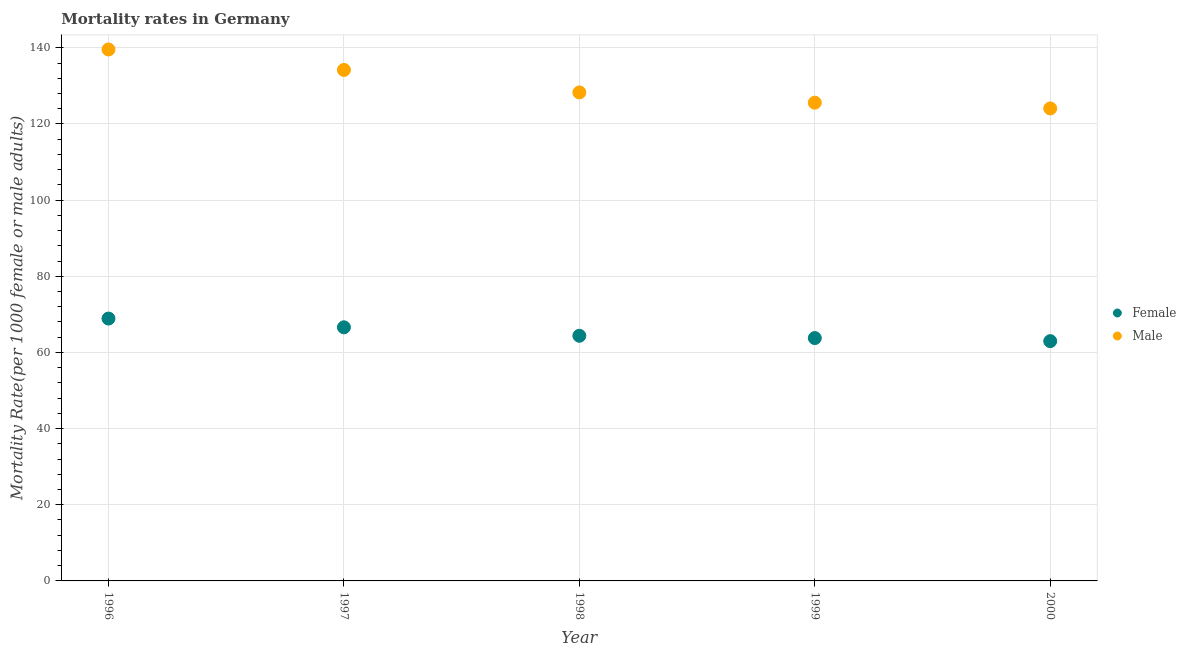How many different coloured dotlines are there?
Provide a succinct answer. 2. Is the number of dotlines equal to the number of legend labels?
Provide a short and direct response. Yes. What is the male mortality rate in 1996?
Your answer should be compact. 139.57. Across all years, what is the maximum male mortality rate?
Provide a short and direct response. 139.57. Across all years, what is the minimum male mortality rate?
Your response must be concise. 124.08. In which year was the female mortality rate minimum?
Provide a short and direct response. 2000. What is the total male mortality rate in the graph?
Offer a terse response. 651.74. What is the difference between the female mortality rate in 1999 and that in 2000?
Your response must be concise. 0.81. What is the difference between the female mortality rate in 1999 and the male mortality rate in 2000?
Your response must be concise. -60.3. What is the average male mortality rate per year?
Provide a succinct answer. 130.35. In the year 1998, what is the difference between the male mortality rate and female mortality rate?
Offer a terse response. 63.91. What is the ratio of the male mortality rate in 1998 to that in 2000?
Provide a succinct answer. 1.03. Is the male mortality rate in 1998 less than that in 1999?
Ensure brevity in your answer.  No. What is the difference between the highest and the second highest female mortality rate?
Your response must be concise. 2.3. What is the difference between the highest and the lowest male mortality rate?
Your answer should be compact. 15.49. In how many years, is the female mortality rate greater than the average female mortality rate taken over all years?
Make the answer very short. 2. Does the female mortality rate monotonically increase over the years?
Offer a terse response. No. Is the male mortality rate strictly greater than the female mortality rate over the years?
Provide a succinct answer. Yes. What is the difference between two consecutive major ticks on the Y-axis?
Ensure brevity in your answer.  20. Does the graph contain any zero values?
Provide a succinct answer. No. Does the graph contain grids?
Provide a short and direct response. Yes. What is the title of the graph?
Offer a very short reply. Mortality rates in Germany. What is the label or title of the X-axis?
Your answer should be very brief. Year. What is the label or title of the Y-axis?
Offer a very short reply. Mortality Rate(per 1000 female or male adults). What is the Mortality Rate(per 1000 female or male adults) in Female in 1996?
Your answer should be compact. 68.9. What is the Mortality Rate(per 1000 female or male adults) in Male in 1996?
Offer a very short reply. 139.57. What is the Mortality Rate(per 1000 female or male adults) in Female in 1997?
Your response must be concise. 66.61. What is the Mortality Rate(per 1000 female or male adults) of Male in 1997?
Ensure brevity in your answer.  134.2. What is the Mortality Rate(per 1000 female or male adults) in Female in 1998?
Provide a succinct answer. 64.38. What is the Mortality Rate(per 1000 female or male adults) of Male in 1998?
Provide a succinct answer. 128.29. What is the Mortality Rate(per 1000 female or male adults) in Female in 1999?
Give a very brief answer. 63.78. What is the Mortality Rate(per 1000 female or male adults) of Male in 1999?
Give a very brief answer. 125.6. What is the Mortality Rate(per 1000 female or male adults) of Female in 2000?
Provide a succinct answer. 62.97. What is the Mortality Rate(per 1000 female or male adults) in Male in 2000?
Keep it short and to the point. 124.08. Across all years, what is the maximum Mortality Rate(per 1000 female or male adults) in Female?
Ensure brevity in your answer.  68.9. Across all years, what is the maximum Mortality Rate(per 1000 female or male adults) of Male?
Provide a short and direct response. 139.57. Across all years, what is the minimum Mortality Rate(per 1000 female or male adults) of Female?
Offer a terse response. 62.97. Across all years, what is the minimum Mortality Rate(per 1000 female or male adults) in Male?
Your response must be concise. 124.08. What is the total Mortality Rate(per 1000 female or male adults) in Female in the graph?
Offer a very short reply. 326.64. What is the total Mortality Rate(per 1000 female or male adults) in Male in the graph?
Give a very brief answer. 651.74. What is the difference between the Mortality Rate(per 1000 female or male adults) of Female in 1996 and that in 1997?
Ensure brevity in your answer.  2.3. What is the difference between the Mortality Rate(per 1000 female or male adults) of Male in 1996 and that in 1997?
Your response must be concise. 5.38. What is the difference between the Mortality Rate(per 1000 female or male adults) of Female in 1996 and that in 1998?
Keep it short and to the point. 4.52. What is the difference between the Mortality Rate(per 1000 female or male adults) in Male in 1996 and that in 1998?
Your response must be concise. 11.29. What is the difference between the Mortality Rate(per 1000 female or male adults) in Female in 1996 and that in 1999?
Keep it short and to the point. 5.12. What is the difference between the Mortality Rate(per 1000 female or male adults) of Male in 1996 and that in 1999?
Make the answer very short. 13.98. What is the difference between the Mortality Rate(per 1000 female or male adults) of Female in 1996 and that in 2000?
Provide a short and direct response. 5.93. What is the difference between the Mortality Rate(per 1000 female or male adults) of Male in 1996 and that in 2000?
Offer a very short reply. 15.49. What is the difference between the Mortality Rate(per 1000 female or male adults) of Female in 1997 and that in 1998?
Offer a very short reply. 2.23. What is the difference between the Mortality Rate(per 1000 female or male adults) of Male in 1997 and that in 1998?
Keep it short and to the point. 5.91. What is the difference between the Mortality Rate(per 1000 female or male adults) of Female in 1997 and that in 1999?
Offer a very short reply. 2.83. What is the difference between the Mortality Rate(per 1000 female or male adults) in Male in 1997 and that in 1999?
Give a very brief answer. 8.6. What is the difference between the Mortality Rate(per 1000 female or male adults) of Female in 1997 and that in 2000?
Offer a terse response. 3.63. What is the difference between the Mortality Rate(per 1000 female or male adults) in Male in 1997 and that in 2000?
Ensure brevity in your answer.  10.11. What is the difference between the Mortality Rate(per 1000 female or male adults) in Female in 1998 and that in 1999?
Your answer should be compact. 0.6. What is the difference between the Mortality Rate(per 1000 female or male adults) of Male in 1998 and that in 1999?
Your answer should be compact. 2.69. What is the difference between the Mortality Rate(per 1000 female or male adults) of Female in 1998 and that in 2000?
Provide a short and direct response. 1.41. What is the difference between the Mortality Rate(per 1000 female or male adults) in Male in 1998 and that in 2000?
Keep it short and to the point. 4.21. What is the difference between the Mortality Rate(per 1000 female or male adults) in Female in 1999 and that in 2000?
Keep it short and to the point. 0.81. What is the difference between the Mortality Rate(per 1000 female or male adults) of Male in 1999 and that in 2000?
Offer a very short reply. 1.51. What is the difference between the Mortality Rate(per 1000 female or male adults) in Female in 1996 and the Mortality Rate(per 1000 female or male adults) in Male in 1997?
Offer a terse response. -65.29. What is the difference between the Mortality Rate(per 1000 female or male adults) of Female in 1996 and the Mortality Rate(per 1000 female or male adults) of Male in 1998?
Provide a short and direct response. -59.39. What is the difference between the Mortality Rate(per 1000 female or male adults) in Female in 1996 and the Mortality Rate(per 1000 female or male adults) in Male in 1999?
Offer a very short reply. -56.7. What is the difference between the Mortality Rate(per 1000 female or male adults) of Female in 1996 and the Mortality Rate(per 1000 female or male adults) of Male in 2000?
Make the answer very short. -55.18. What is the difference between the Mortality Rate(per 1000 female or male adults) in Female in 1997 and the Mortality Rate(per 1000 female or male adults) in Male in 1998?
Your answer should be compact. -61.68. What is the difference between the Mortality Rate(per 1000 female or male adults) of Female in 1997 and the Mortality Rate(per 1000 female or male adults) of Male in 1999?
Offer a very short reply. -58.99. What is the difference between the Mortality Rate(per 1000 female or male adults) in Female in 1997 and the Mortality Rate(per 1000 female or male adults) in Male in 2000?
Ensure brevity in your answer.  -57.48. What is the difference between the Mortality Rate(per 1000 female or male adults) in Female in 1998 and the Mortality Rate(per 1000 female or male adults) in Male in 1999?
Your response must be concise. -61.22. What is the difference between the Mortality Rate(per 1000 female or male adults) in Female in 1998 and the Mortality Rate(per 1000 female or male adults) in Male in 2000?
Give a very brief answer. -59.7. What is the difference between the Mortality Rate(per 1000 female or male adults) in Female in 1999 and the Mortality Rate(per 1000 female or male adults) in Male in 2000?
Your answer should be compact. -60.3. What is the average Mortality Rate(per 1000 female or male adults) in Female per year?
Your answer should be compact. 65.33. What is the average Mortality Rate(per 1000 female or male adults) of Male per year?
Your response must be concise. 130.35. In the year 1996, what is the difference between the Mortality Rate(per 1000 female or male adults) of Female and Mortality Rate(per 1000 female or male adults) of Male?
Make the answer very short. -70.67. In the year 1997, what is the difference between the Mortality Rate(per 1000 female or male adults) of Female and Mortality Rate(per 1000 female or male adults) of Male?
Provide a succinct answer. -67.59. In the year 1998, what is the difference between the Mortality Rate(per 1000 female or male adults) in Female and Mortality Rate(per 1000 female or male adults) in Male?
Provide a short and direct response. -63.91. In the year 1999, what is the difference between the Mortality Rate(per 1000 female or male adults) of Female and Mortality Rate(per 1000 female or male adults) of Male?
Your answer should be compact. -61.82. In the year 2000, what is the difference between the Mortality Rate(per 1000 female or male adults) in Female and Mortality Rate(per 1000 female or male adults) in Male?
Your response must be concise. -61.11. What is the ratio of the Mortality Rate(per 1000 female or male adults) in Female in 1996 to that in 1997?
Ensure brevity in your answer.  1.03. What is the ratio of the Mortality Rate(per 1000 female or male adults) in Male in 1996 to that in 1997?
Offer a terse response. 1.04. What is the ratio of the Mortality Rate(per 1000 female or male adults) in Female in 1996 to that in 1998?
Make the answer very short. 1.07. What is the ratio of the Mortality Rate(per 1000 female or male adults) of Male in 1996 to that in 1998?
Your response must be concise. 1.09. What is the ratio of the Mortality Rate(per 1000 female or male adults) of Female in 1996 to that in 1999?
Provide a succinct answer. 1.08. What is the ratio of the Mortality Rate(per 1000 female or male adults) in Male in 1996 to that in 1999?
Make the answer very short. 1.11. What is the ratio of the Mortality Rate(per 1000 female or male adults) of Female in 1996 to that in 2000?
Your answer should be very brief. 1.09. What is the ratio of the Mortality Rate(per 1000 female or male adults) in Male in 1996 to that in 2000?
Your response must be concise. 1.12. What is the ratio of the Mortality Rate(per 1000 female or male adults) in Female in 1997 to that in 1998?
Your answer should be very brief. 1.03. What is the ratio of the Mortality Rate(per 1000 female or male adults) of Male in 1997 to that in 1998?
Your answer should be compact. 1.05. What is the ratio of the Mortality Rate(per 1000 female or male adults) in Female in 1997 to that in 1999?
Give a very brief answer. 1.04. What is the ratio of the Mortality Rate(per 1000 female or male adults) in Male in 1997 to that in 1999?
Your response must be concise. 1.07. What is the ratio of the Mortality Rate(per 1000 female or male adults) of Female in 1997 to that in 2000?
Offer a very short reply. 1.06. What is the ratio of the Mortality Rate(per 1000 female or male adults) of Male in 1997 to that in 2000?
Keep it short and to the point. 1.08. What is the ratio of the Mortality Rate(per 1000 female or male adults) in Female in 1998 to that in 1999?
Your answer should be very brief. 1.01. What is the ratio of the Mortality Rate(per 1000 female or male adults) in Male in 1998 to that in 1999?
Offer a terse response. 1.02. What is the ratio of the Mortality Rate(per 1000 female or male adults) of Female in 1998 to that in 2000?
Keep it short and to the point. 1.02. What is the ratio of the Mortality Rate(per 1000 female or male adults) of Male in 1998 to that in 2000?
Offer a terse response. 1.03. What is the ratio of the Mortality Rate(per 1000 female or male adults) in Female in 1999 to that in 2000?
Ensure brevity in your answer.  1.01. What is the ratio of the Mortality Rate(per 1000 female or male adults) of Male in 1999 to that in 2000?
Offer a terse response. 1.01. What is the difference between the highest and the second highest Mortality Rate(per 1000 female or male adults) of Female?
Ensure brevity in your answer.  2.3. What is the difference between the highest and the second highest Mortality Rate(per 1000 female or male adults) in Male?
Your answer should be compact. 5.38. What is the difference between the highest and the lowest Mortality Rate(per 1000 female or male adults) of Female?
Provide a succinct answer. 5.93. What is the difference between the highest and the lowest Mortality Rate(per 1000 female or male adults) in Male?
Ensure brevity in your answer.  15.49. 